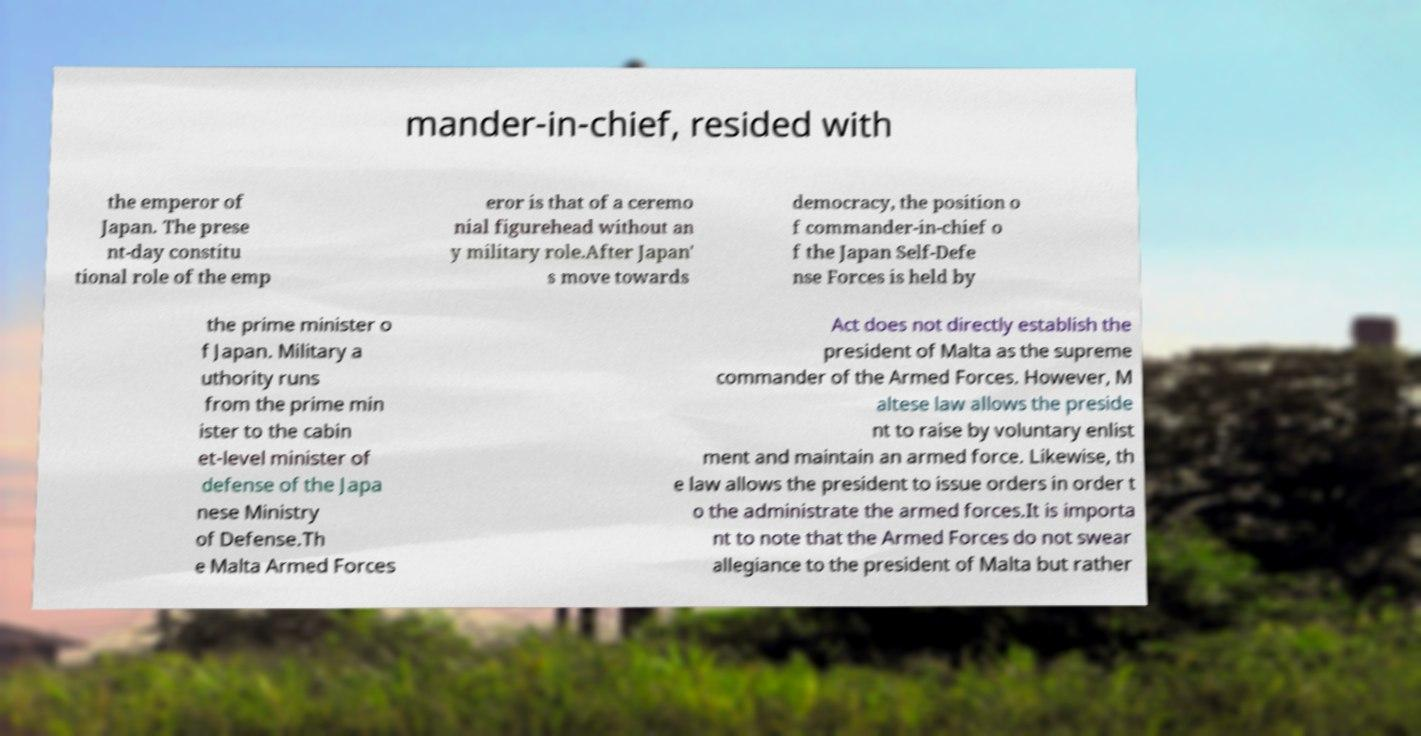I need the written content from this picture converted into text. Can you do that? mander-in-chief, resided with the emperor of Japan. The prese nt-day constitu tional role of the emp eror is that of a ceremo nial figurehead without an y military role.After Japan' s move towards democracy, the position o f commander-in-chief o f the Japan Self-Defe nse Forces is held by the prime minister o f Japan. Military a uthority runs from the prime min ister to the cabin et-level minister of defense of the Japa nese Ministry of Defense.Th e Malta Armed Forces Act does not directly establish the president of Malta as the supreme commander of the Armed Forces. However, M altese law allows the preside nt to raise by voluntary enlist ment and maintain an armed force. Likewise, th e law allows the president to issue orders in order t o the administrate the armed forces.It is importa nt to note that the Armed Forces do not swear allegiance to the president of Malta but rather 